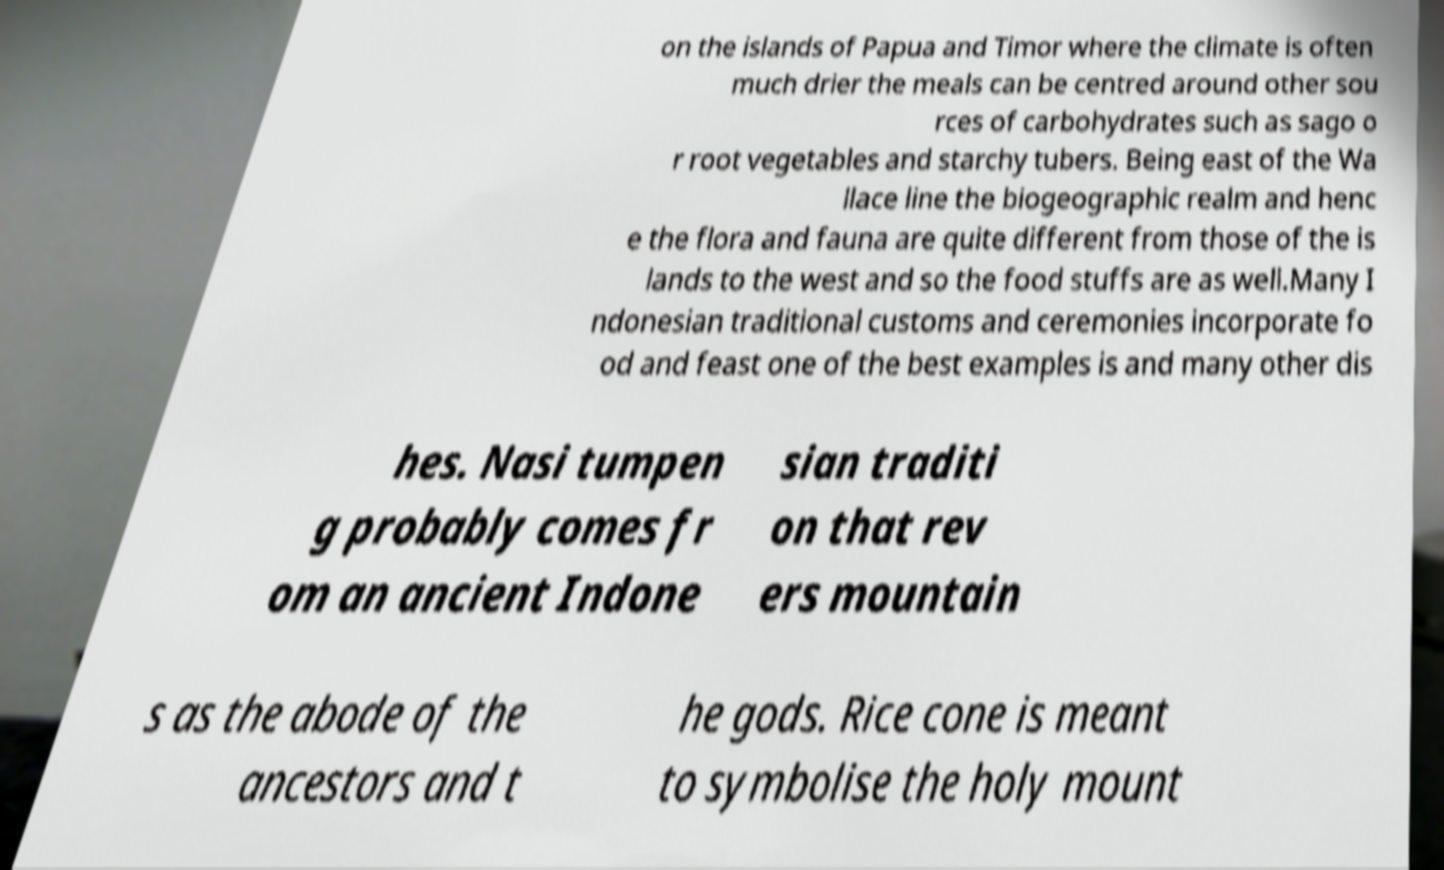Could you extract and type out the text from this image? on the islands of Papua and Timor where the climate is often much drier the meals can be centred around other sou rces of carbohydrates such as sago o r root vegetables and starchy tubers. Being east of the Wa llace line the biogeographic realm and henc e the flora and fauna are quite different from those of the is lands to the west and so the food stuffs are as well.Many I ndonesian traditional customs and ceremonies incorporate fo od and feast one of the best examples is and many other dis hes. Nasi tumpen g probably comes fr om an ancient Indone sian traditi on that rev ers mountain s as the abode of the ancestors and t he gods. Rice cone is meant to symbolise the holy mount 